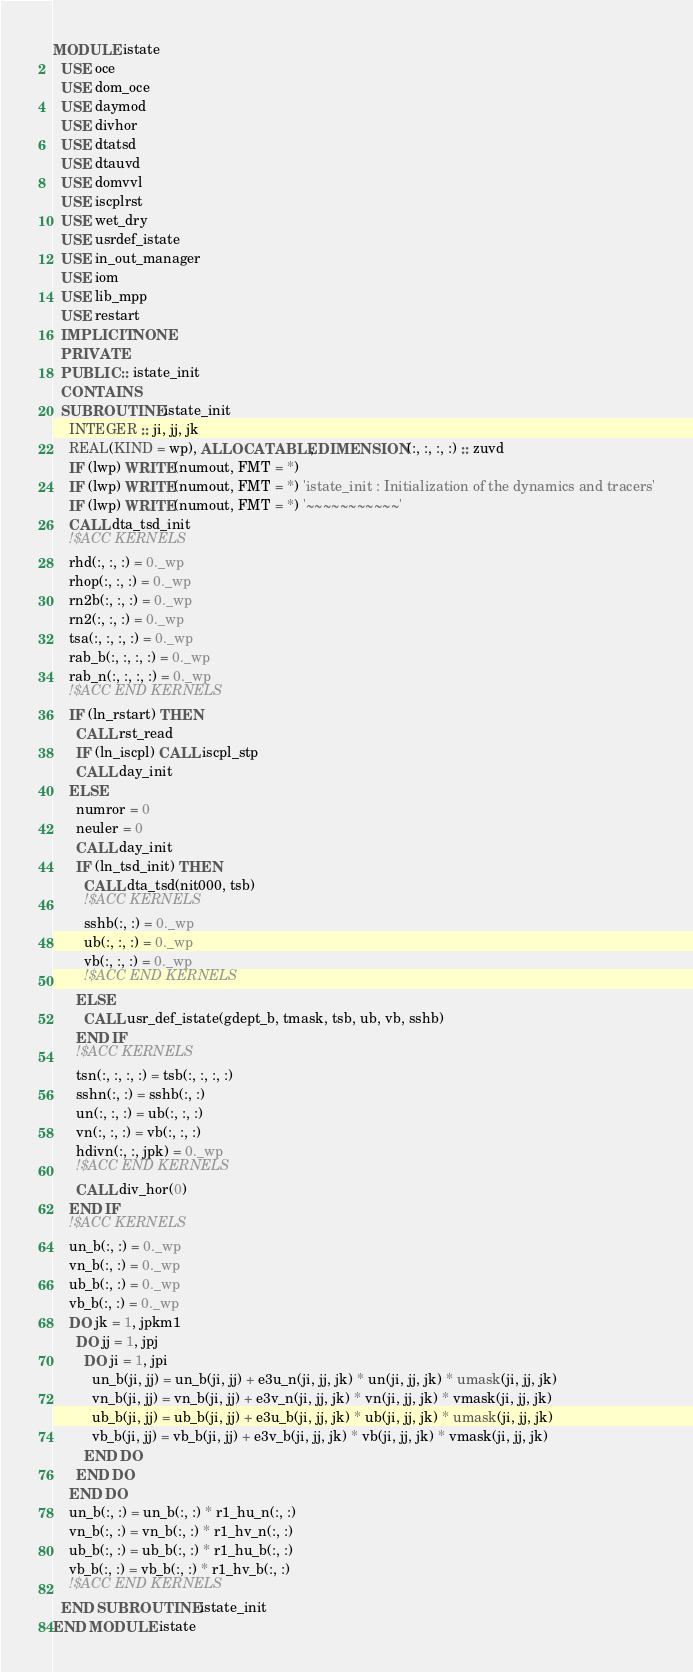Convert code to text. <code><loc_0><loc_0><loc_500><loc_500><_FORTRAN_>MODULE istate
  USE oce
  USE dom_oce
  USE daymod
  USE divhor
  USE dtatsd
  USE dtauvd
  USE domvvl
  USE iscplrst
  USE wet_dry
  USE usrdef_istate
  USE in_out_manager
  USE iom
  USE lib_mpp
  USE restart
  IMPLICIT NONE
  PRIVATE
  PUBLIC :: istate_init
  CONTAINS
  SUBROUTINE istate_init
    INTEGER :: ji, jj, jk
    REAL(KIND = wp), ALLOCATABLE, DIMENSION(:, :, :, :) :: zuvd
    IF (lwp) WRITE(numout, FMT = *)
    IF (lwp) WRITE(numout, FMT = *) 'istate_init : Initialization of the dynamics and tracers'
    IF (lwp) WRITE(numout, FMT = *) '~~~~~~~~~~~'
    CALL dta_tsd_init
    !$ACC KERNELS
    rhd(:, :, :) = 0._wp
    rhop(:, :, :) = 0._wp
    rn2b(:, :, :) = 0._wp
    rn2(:, :, :) = 0._wp
    tsa(:, :, :, :) = 0._wp
    rab_b(:, :, :, :) = 0._wp
    rab_n(:, :, :, :) = 0._wp
    !$ACC END KERNELS
    IF (ln_rstart) THEN
      CALL rst_read
      IF (ln_iscpl) CALL iscpl_stp
      CALL day_init
    ELSE
      numror = 0
      neuler = 0
      CALL day_init
      IF (ln_tsd_init) THEN
        CALL dta_tsd(nit000, tsb)
        !$ACC KERNELS
        sshb(:, :) = 0._wp
        ub(:, :, :) = 0._wp
        vb(:, :, :) = 0._wp
        !$ACC END KERNELS
      ELSE
        CALL usr_def_istate(gdept_b, tmask, tsb, ub, vb, sshb)
      END IF
      !$ACC KERNELS
      tsn(:, :, :, :) = tsb(:, :, :, :)
      sshn(:, :) = sshb(:, :)
      un(:, :, :) = ub(:, :, :)
      vn(:, :, :) = vb(:, :, :)
      hdivn(:, :, jpk) = 0._wp
      !$ACC END KERNELS
      CALL div_hor(0)
    END IF
    !$ACC KERNELS
    un_b(:, :) = 0._wp
    vn_b(:, :) = 0._wp
    ub_b(:, :) = 0._wp
    vb_b(:, :) = 0._wp
    DO jk = 1, jpkm1
      DO jj = 1, jpj
        DO ji = 1, jpi
          un_b(ji, jj) = un_b(ji, jj) + e3u_n(ji, jj, jk) * un(ji, jj, jk) * umask(ji, jj, jk)
          vn_b(ji, jj) = vn_b(ji, jj) + e3v_n(ji, jj, jk) * vn(ji, jj, jk) * vmask(ji, jj, jk)
          ub_b(ji, jj) = ub_b(ji, jj) + e3u_b(ji, jj, jk) * ub(ji, jj, jk) * umask(ji, jj, jk)
          vb_b(ji, jj) = vb_b(ji, jj) + e3v_b(ji, jj, jk) * vb(ji, jj, jk) * vmask(ji, jj, jk)
        END DO
      END DO
    END DO
    un_b(:, :) = un_b(:, :) * r1_hu_n(:, :)
    vn_b(:, :) = vn_b(:, :) * r1_hv_n(:, :)
    ub_b(:, :) = ub_b(:, :) * r1_hu_b(:, :)
    vb_b(:, :) = vb_b(:, :) * r1_hv_b(:, :)
    !$ACC END KERNELS
  END SUBROUTINE istate_init
END MODULE istate</code> 